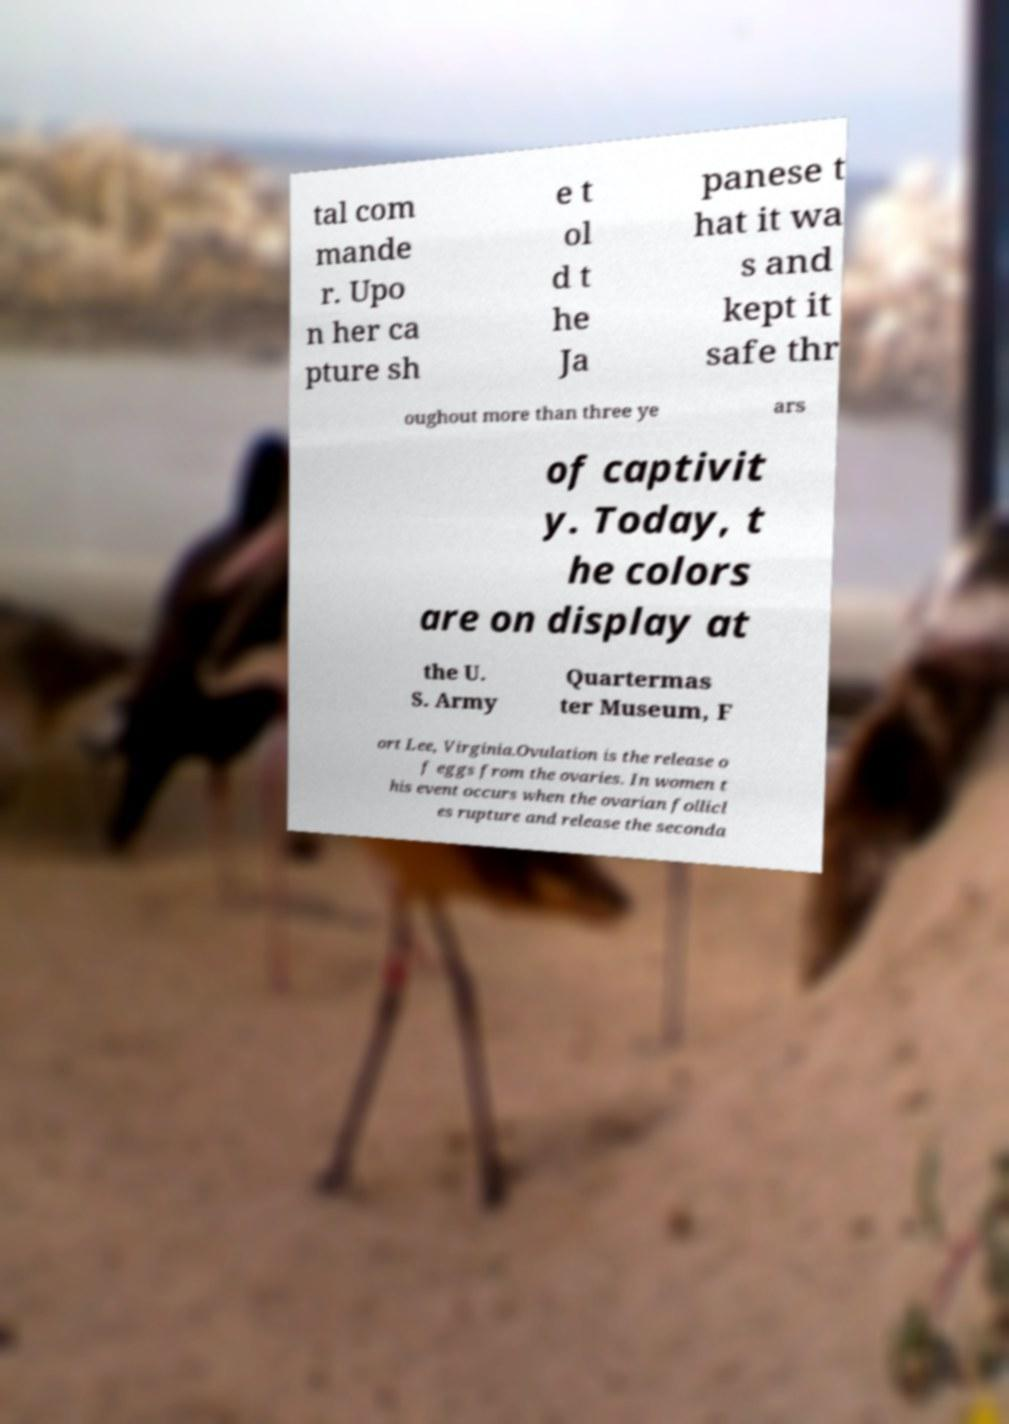Please read and relay the text visible in this image. What does it say? tal com mande r. Upo n her ca pture sh e t ol d t he Ja panese t hat it wa s and kept it safe thr oughout more than three ye ars of captivit y. Today, t he colors are on display at the U. S. Army Quartermas ter Museum, F ort Lee, Virginia.Ovulation is the release o f eggs from the ovaries. In women t his event occurs when the ovarian follicl es rupture and release the seconda 